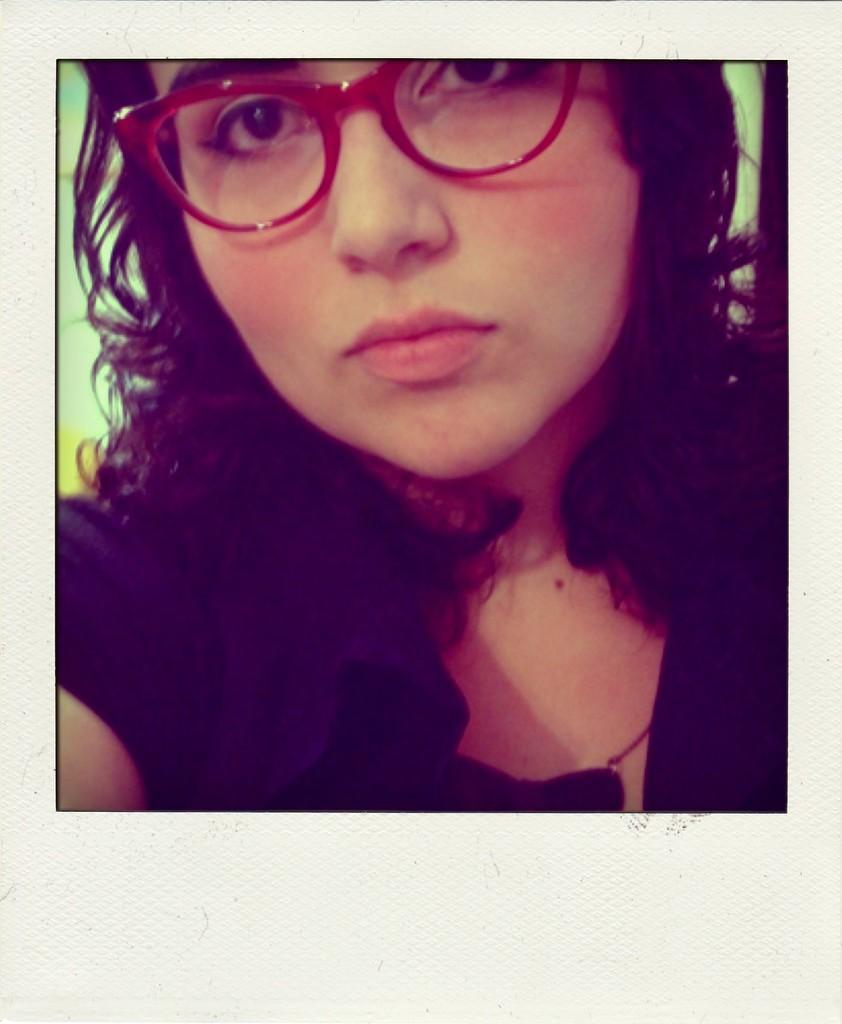Please provide a concise description of this image. In this image I can see a woman is looking at this side, she wore red color spectacles and a black color t-shirt. 